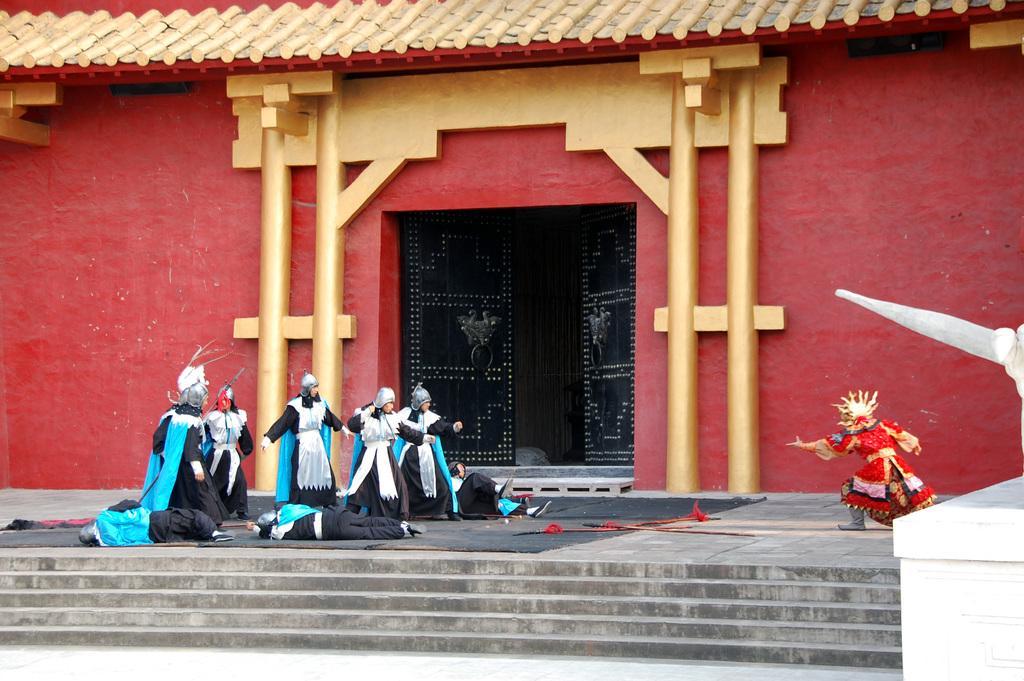Can you describe this image briefly? In this image in the center there are steps and there are persons standing and laying on the ground, In the background there is a door which is black in colour and there are pillars and there is a wall. On the top there is a wooden shelter. On the right side there is an object which is white in colour and there is a wall. 